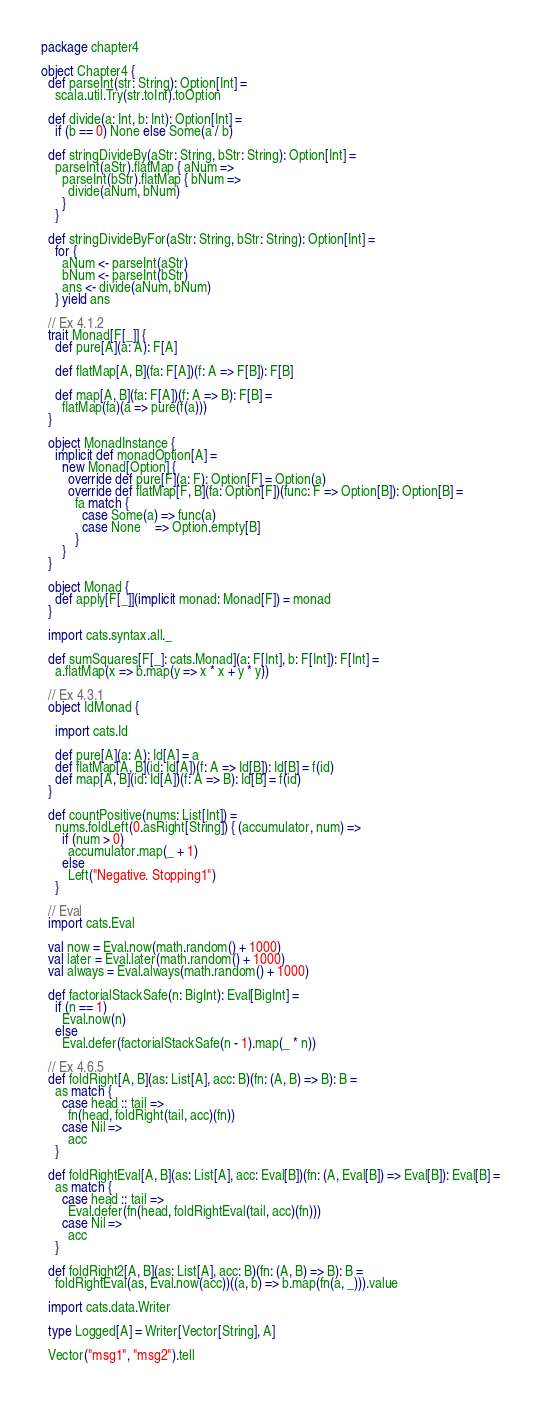<code> <loc_0><loc_0><loc_500><loc_500><_Scala_>package chapter4

object Chapter4 {
  def parseInt(str: String): Option[Int] =
    scala.util.Try(str.toInt).toOption

  def divide(a: Int, b: Int): Option[Int] =
    if (b == 0) None else Some(a / b)

  def stringDivideBy(aStr: String, bStr: String): Option[Int] =
    parseInt(aStr).flatMap { aNum =>
      parseInt(bStr).flatMap { bNum =>
        divide(aNum, bNum)
      }
    }

  def stringDivideByFor(aStr: String, bStr: String): Option[Int] =
    for {
      aNum <- parseInt(aStr)
      bNum <- parseInt(bStr)
      ans <- divide(aNum, bNum)
    } yield ans

  // Ex 4.1.2
  trait Monad[F[_]] {
    def pure[A](a: A): F[A]

    def flatMap[A, B](fa: F[A])(f: A => F[B]): F[B]

    def map[A, B](fa: F[A])(f: A => B): F[B] =
      flatMap(fa)(a => pure(f(a)))
  }

  object MonadInstance {
    implicit def monadOption[A] =
      new Monad[Option] {
        override def pure[F](a: F): Option[F] = Option(a)
        override def flatMap[F, B](fa: Option[F])(func: F => Option[B]): Option[B] =
          fa match {
            case Some(a) => func(a)
            case None    => Option.empty[B]
          }
      }
  }

  object Monad {
    def apply[F[_]](implicit monad: Monad[F]) = monad
  }

  import cats.syntax.all._

  def sumSquares[F[_]: cats.Monad](a: F[Int], b: F[Int]): F[Int] =
    a.flatMap(x => b.map(y => x * x + y * y))

  // Ex 4.3.1
  object IdMonad {

    import cats.Id

    def pure[A](a: A): Id[A] = a
    def flatMap[A, B](id: Id[A])(f: A => Id[B]): Id[B] = f(id)
    def map[A, B](id: Id[A])(f: A => B): Id[B] = f(id)
  }

  def countPositive(nums: List[Int]) =
    nums.foldLeft(0.asRight[String]) { (accumulator, num) =>
      if (num > 0)
        accumulator.map(_ + 1)
      else
        Left("Negative. Stopping1")
    }

  // Eval
  import cats.Eval

  val now = Eval.now(math.random() + 1000)
  val later = Eval.later(math.random() + 1000)
  val always = Eval.always(math.random() + 1000)

  def factorialStackSafe(n: BigInt): Eval[BigInt] =
    if (n == 1)
      Eval.now(n)
    else
      Eval.defer(factorialStackSafe(n - 1).map(_ * n))

  // Ex 4.6.5
  def foldRight[A, B](as: List[A], acc: B)(fn: (A, B) => B): B =
    as match {
      case head :: tail =>
        fn(head, foldRight(tail, acc)(fn))
      case Nil =>
        acc
    }

  def foldRightEval[A, B](as: List[A], acc: Eval[B])(fn: (A, Eval[B]) => Eval[B]): Eval[B] =
    as match {
      case head :: tail =>
        Eval.defer(fn(head, foldRightEval(tail, acc)(fn)))
      case Nil =>
        acc
    }

  def foldRight2[A, B](as: List[A], acc: B)(fn: (A, B) => B): B =
    foldRightEval(as, Eval.now(acc))((a, b) => b.map(fn(a, _))).value

  import cats.data.Writer

  type Logged[A] = Writer[Vector[String], A]

  Vector("msg1", "msg2").tell
</code> 